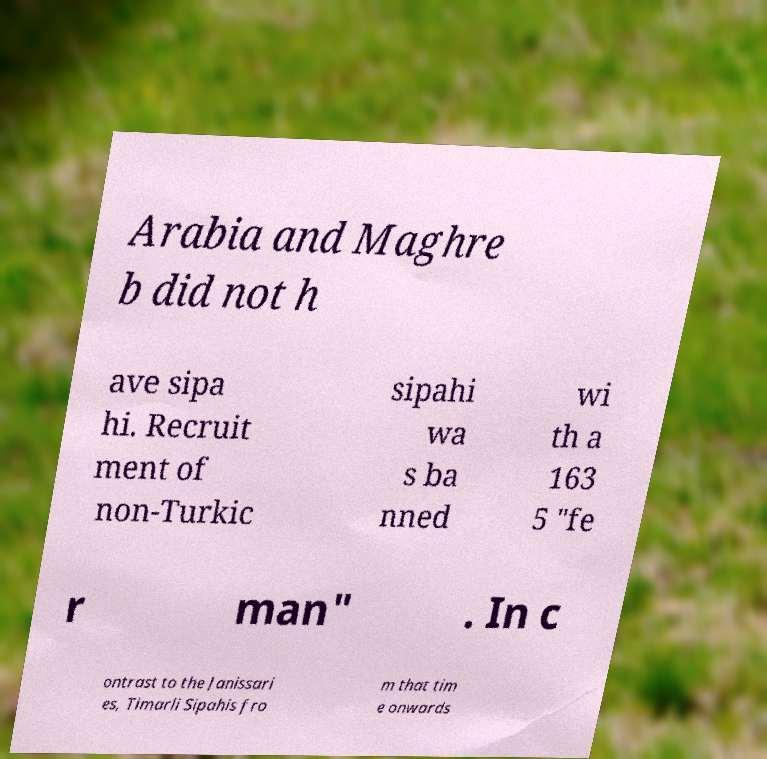There's text embedded in this image that I need extracted. Can you transcribe it verbatim? Arabia and Maghre b did not h ave sipa hi. Recruit ment of non-Turkic sipahi wa s ba nned wi th a 163 5 "fe r man" . In c ontrast to the Janissari es, Timarli Sipahis fro m that tim e onwards 